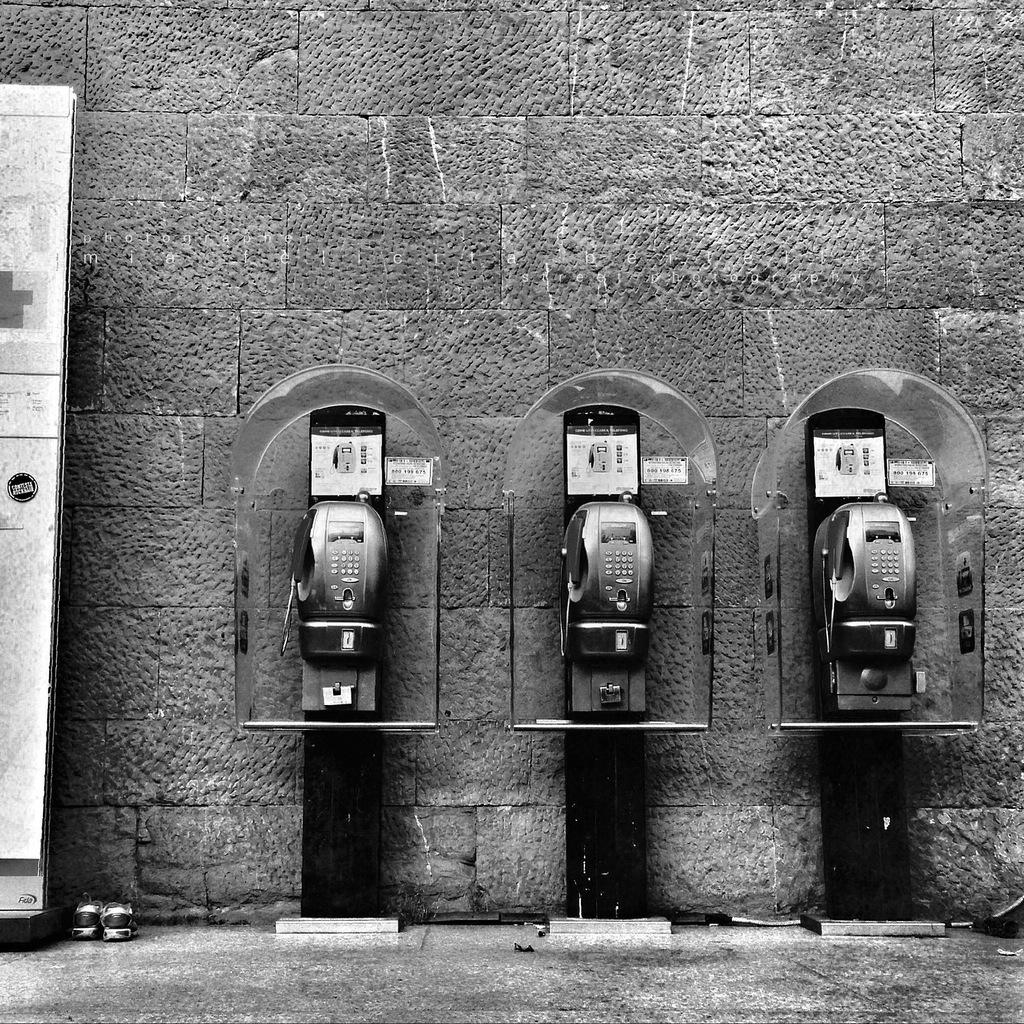How many telephone booths are present in the image? There are three telephone booths in the image. Where are the telephone booths located in relation to other objects? The telephone booths are near a wall. What type of object can be seen in the image besides the telephone booths? There is a stand and footwear visible in the image. What type of tin can be seen in the image? There is no tin present in the image. What day is it in the image? The image does not depict a specific day, so it cannot be determined from the image. 